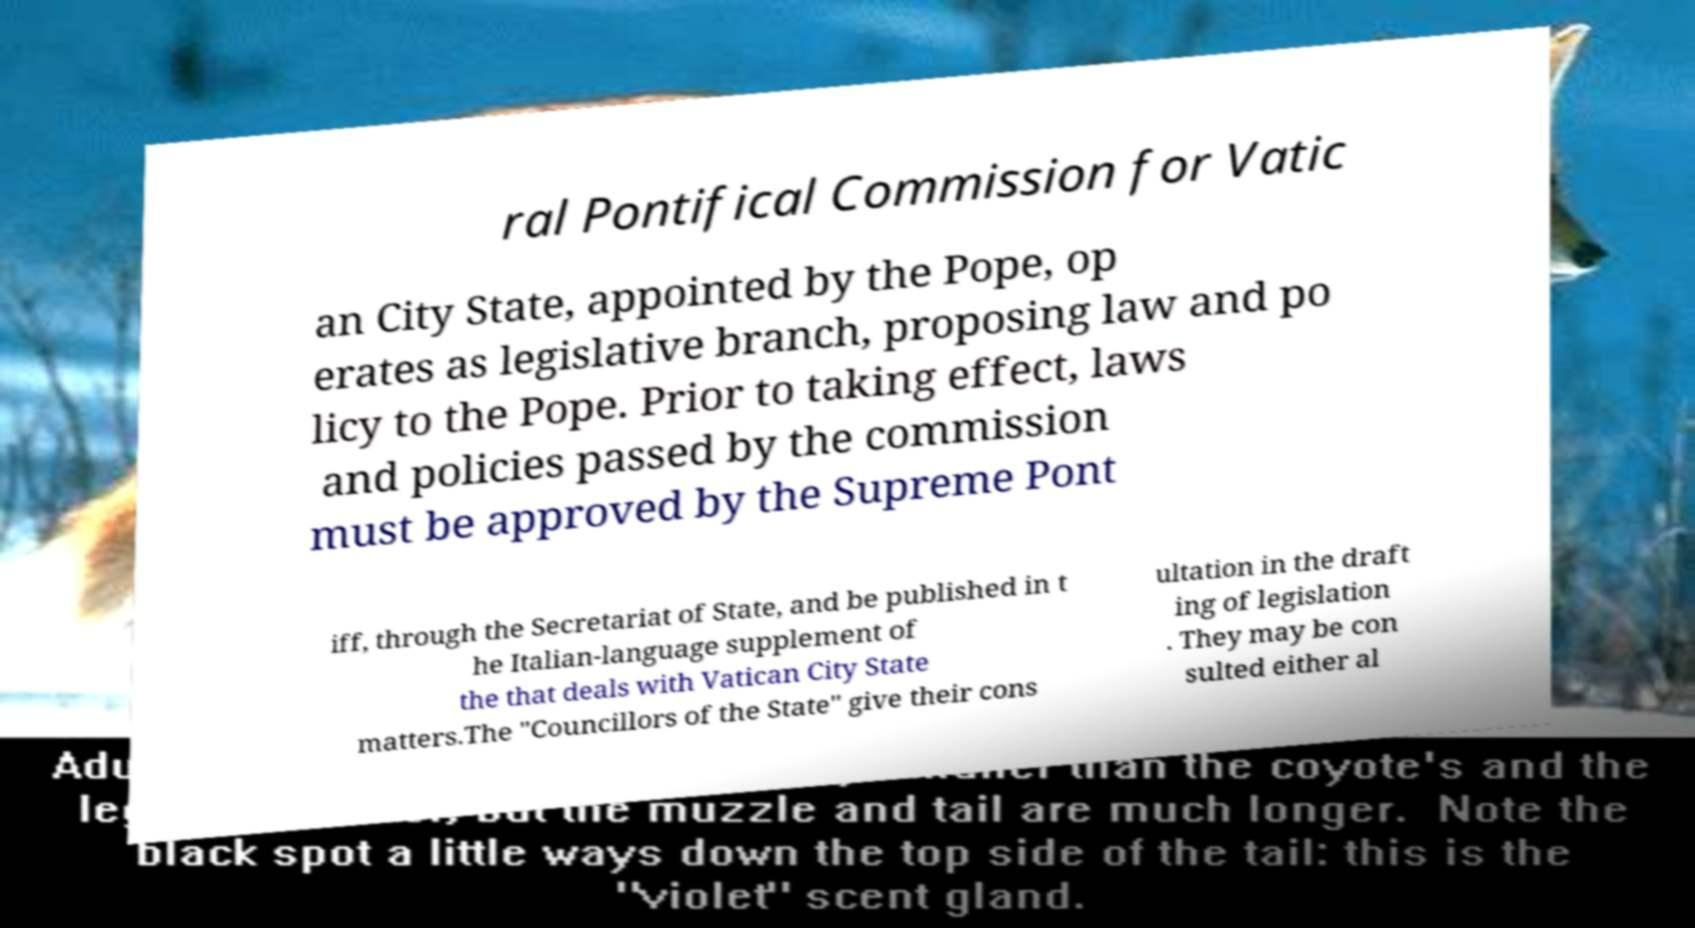For documentation purposes, I need the text within this image transcribed. Could you provide that? ral Pontifical Commission for Vatic an City State, appointed by the Pope, op erates as legislative branch, proposing law and po licy to the Pope. Prior to taking effect, laws and policies passed by the commission must be approved by the Supreme Pont iff, through the Secretariat of State, and be published in t he Italian-language supplement of the that deals with Vatican City State matters.The "Councillors of the State" give their cons ultation in the draft ing of legislation . They may be con sulted either al 